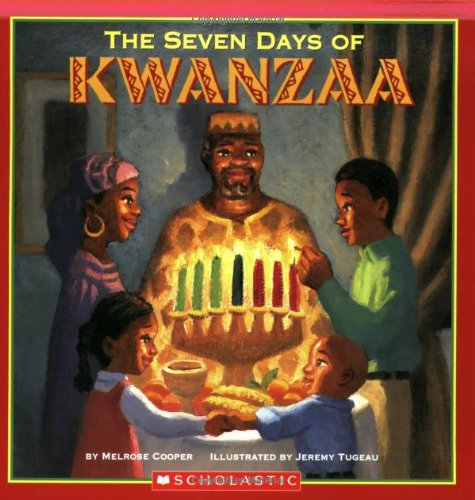Who wrote this book?
Answer the question using a single word or phrase. Melrose Cooper What is the title of this book? Seven Days Of Kwanzaa What is the genre of this book? Children's Books Is this book related to Children's Books? Yes Is this book related to Health, Fitness & Dieting? No 